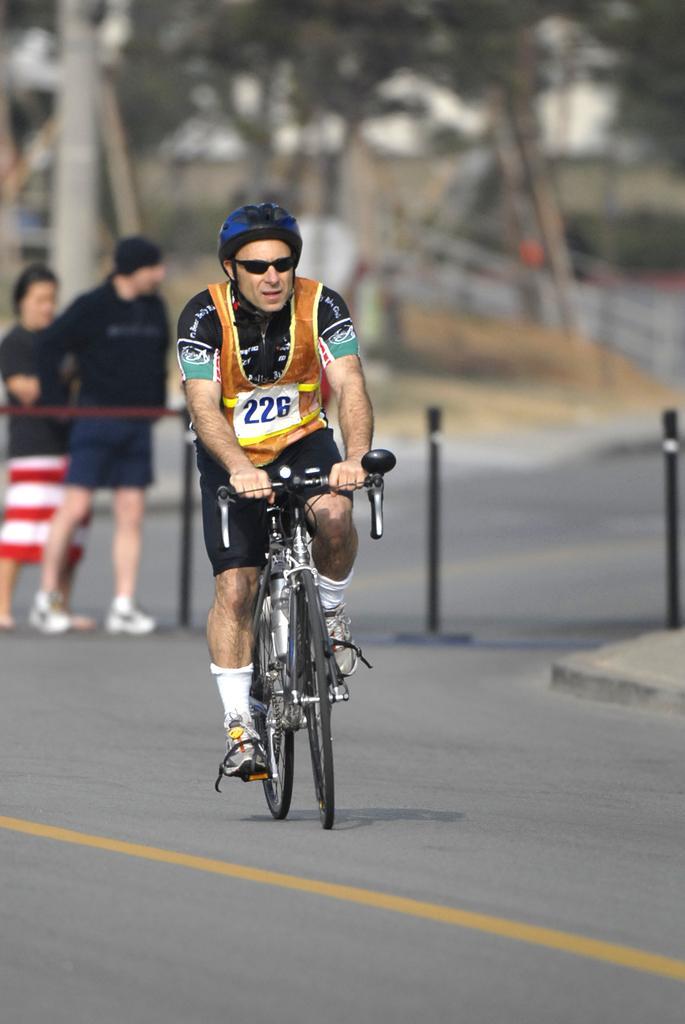How would you summarize this image in a sentence or two? In this image in the center there is one person who is sitting on a cycle and riding, and on the background there are two persons who are standing and on the top there are some trees and some objects are there. 